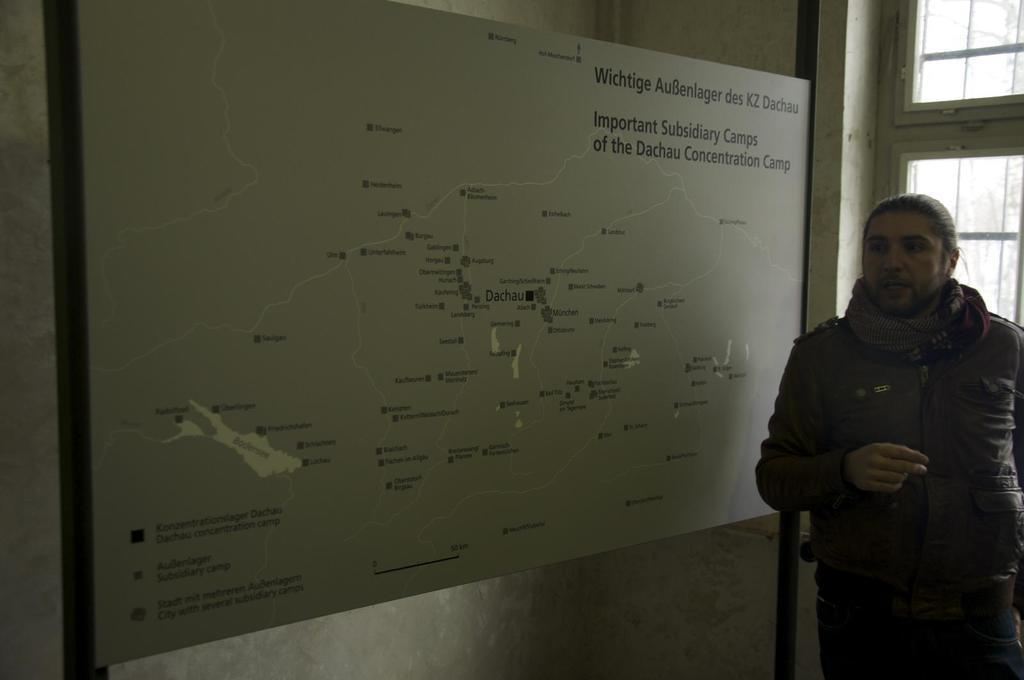In one or two sentences, can you explain what this image depicts? In this image there is a person standing beside a window, there is some text on the board. 